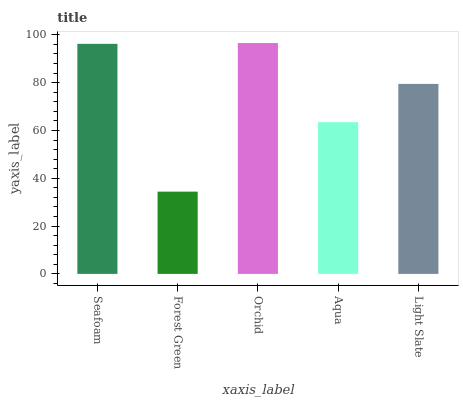Is Forest Green the minimum?
Answer yes or no. Yes. Is Orchid the maximum?
Answer yes or no. Yes. Is Orchid the minimum?
Answer yes or no. No. Is Forest Green the maximum?
Answer yes or no. No. Is Orchid greater than Forest Green?
Answer yes or no. Yes. Is Forest Green less than Orchid?
Answer yes or no. Yes. Is Forest Green greater than Orchid?
Answer yes or no. No. Is Orchid less than Forest Green?
Answer yes or no. No. Is Light Slate the high median?
Answer yes or no. Yes. Is Light Slate the low median?
Answer yes or no. Yes. Is Orchid the high median?
Answer yes or no. No. Is Seafoam the low median?
Answer yes or no. No. 